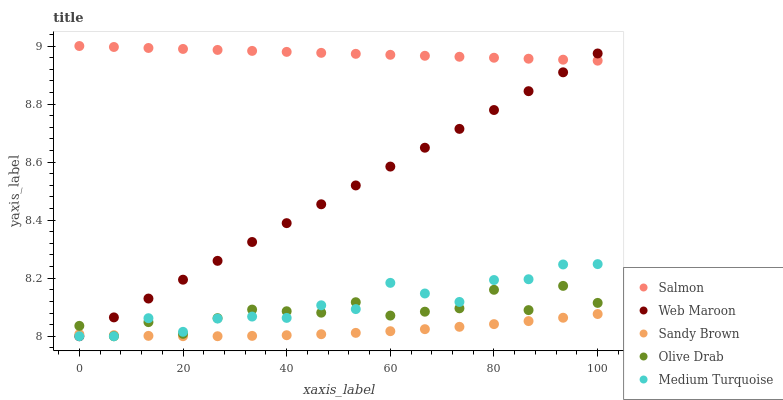Does Sandy Brown have the minimum area under the curve?
Answer yes or no. Yes. Does Salmon have the maximum area under the curve?
Answer yes or no. Yes. Does Medium Turquoise have the minimum area under the curve?
Answer yes or no. No. Does Medium Turquoise have the maximum area under the curve?
Answer yes or no. No. Is Salmon the smoothest?
Answer yes or no. Yes. Is Olive Drab the roughest?
Answer yes or no. Yes. Is Medium Turquoise the smoothest?
Answer yes or no. No. Is Medium Turquoise the roughest?
Answer yes or no. No. Does Web Maroon have the lowest value?
Answer yes or no. Yes. Does Salmon have the lowest value?
Answer yes or no. No. Does Salmon have the highest value?
Answer yes or no. Yes. Does Medium Turquoise have the highest value?
Answer yes or no. No. Is Olive Drab less than Salmon?
Answer yes or no. Yes. Is Salmon greater than Olive Drab?
Answer yes or no. Yes. Does Medium Turquoise intersect Olive Drab?
Answer yes or no. Yes. Is Medium Turquoise less than Olive Drab?
Answer yes or no. No. Is Medium Turquoise greater than Olive Drab?
Answer yes or no. No. Does Olive Drab intersect Salmon?
Answer yes or no. No. 